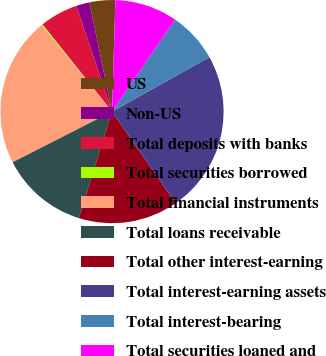<chart> <loc_0><loc_0><loc_500><loc_500><pie_chart><fcel>US<fcel>Non-US<fcel>Total deposits with banks<fcel>Total securities borrowed<fcel>Total financial instruments<fcel>Total loans receivable<fcel>Total other interest-earning<fcel>Total interest-earning assets<fcel>Total interest-bearing<fcel>Total securities loaned and<nl><fcel>3.73%<fcel>1.94%<fcel>5.52%<fcel>0.15%<fcel>21.64%<fcel>12.69%<fcel>14.48%<fcel>23.44%<fcel>7.31%<fcel>9.1%<nl></chart> 